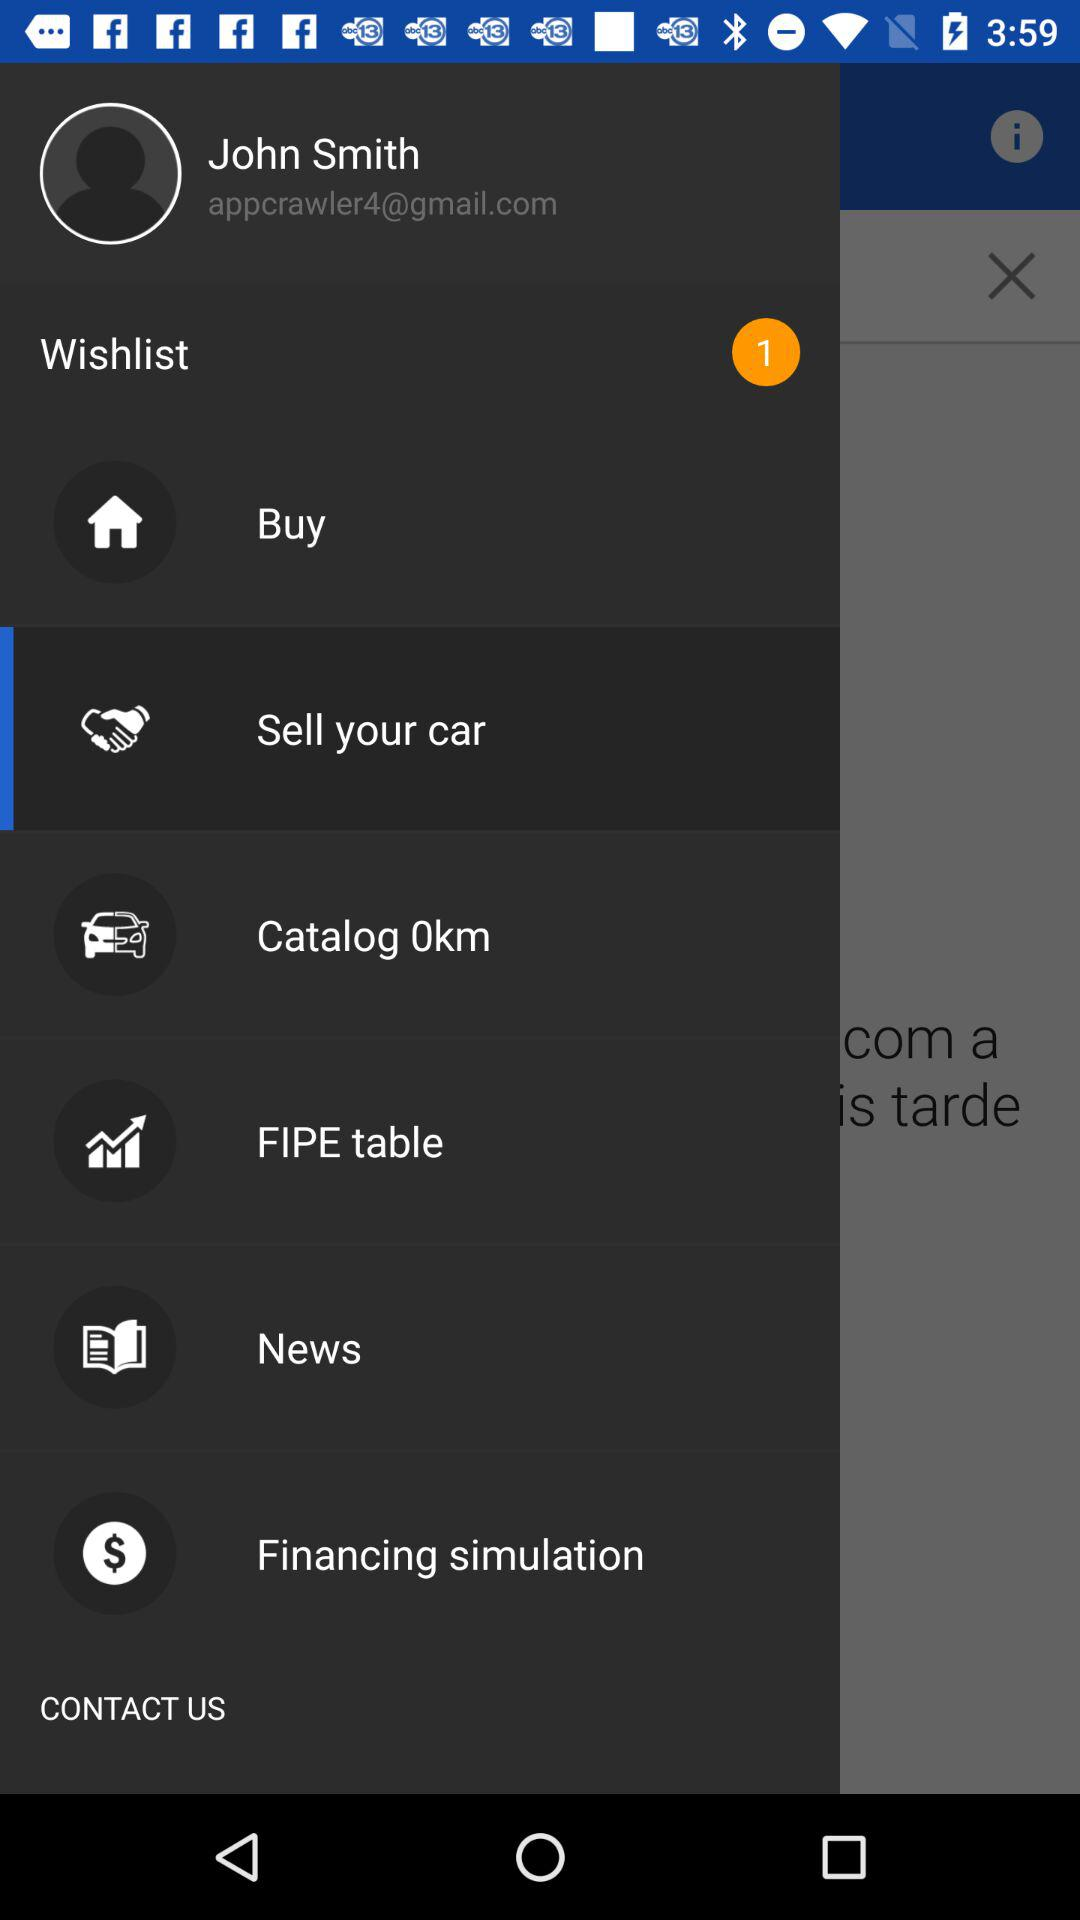What is the user name? The user name is John Smith. 